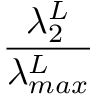<formula> <loc_0><loc_0><loc_500><loc_500>\frac { \lambda _ { 2 } ^ { L } } { \lambda _ { \max } ^ { L } }</formula> 